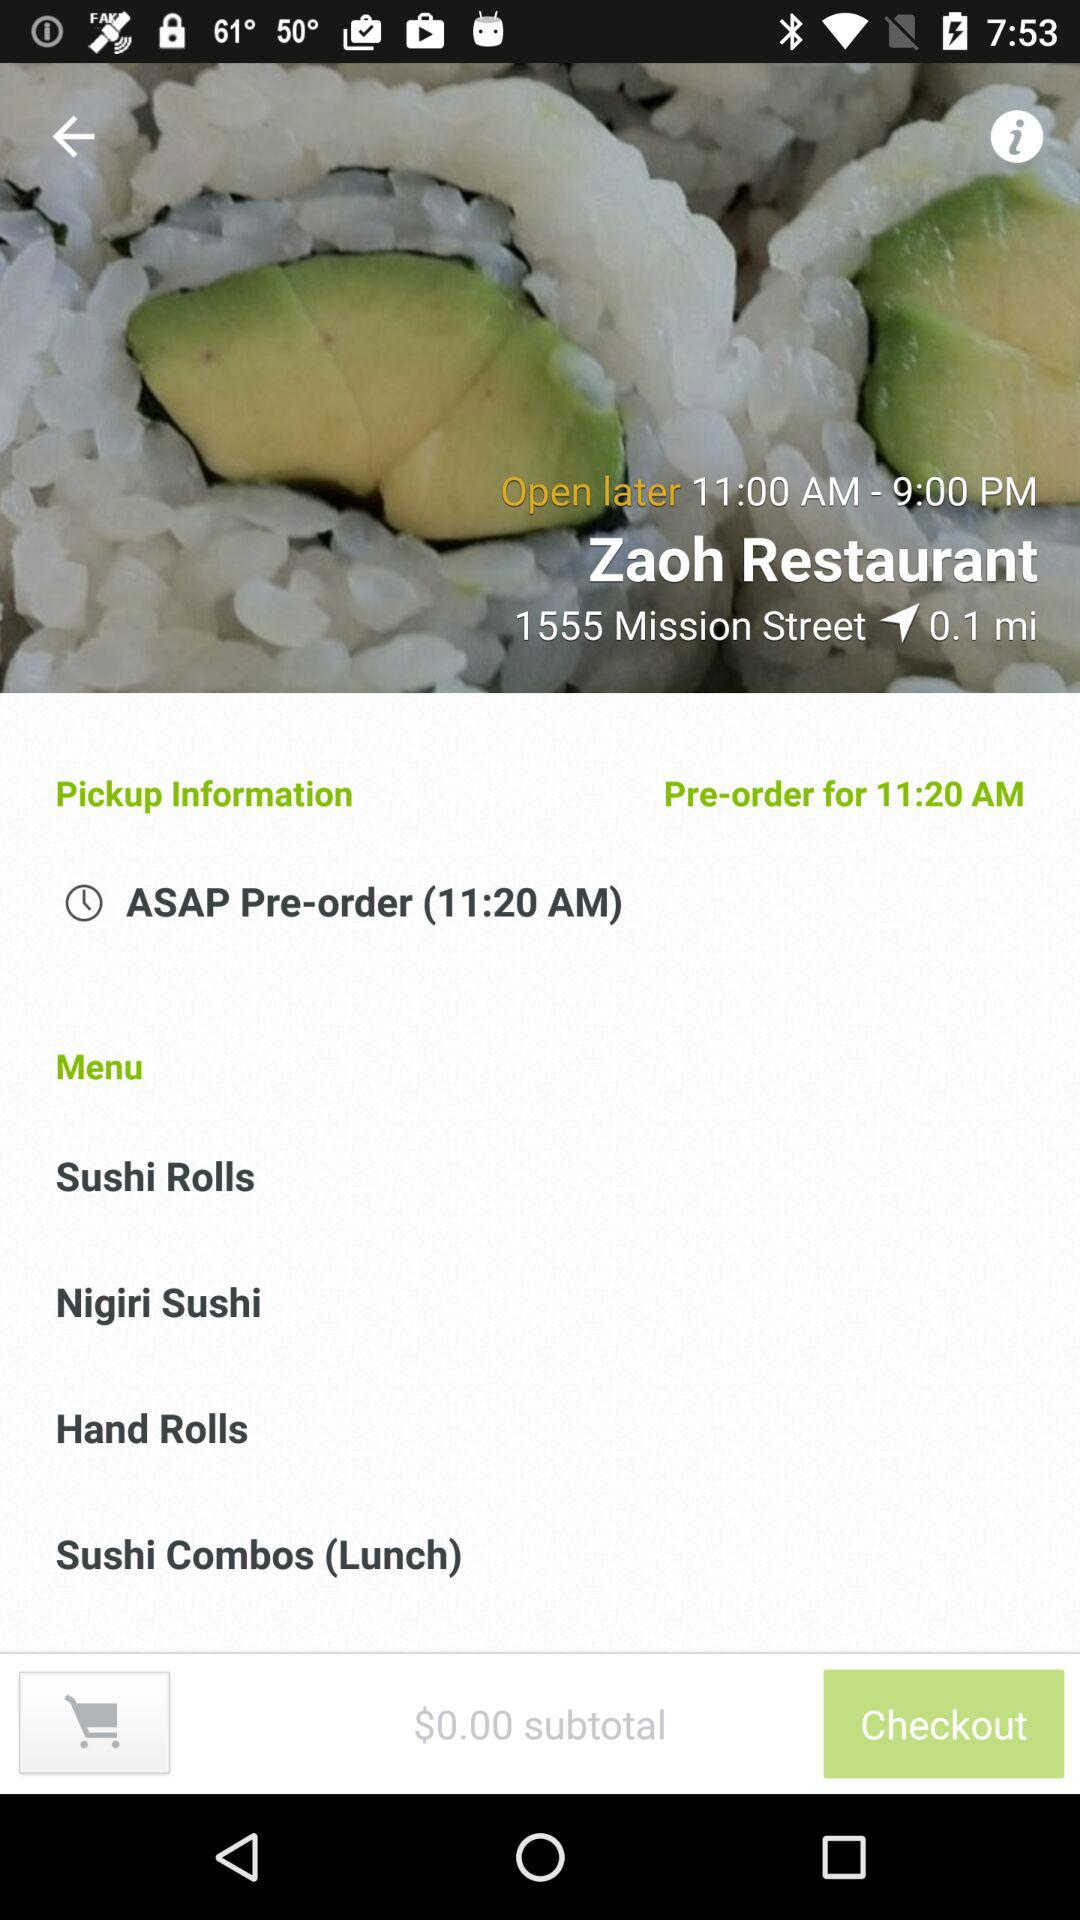Which types of rolls are available? The types of rolls available are "Sushi Rolls" and "Hand Rolls". 